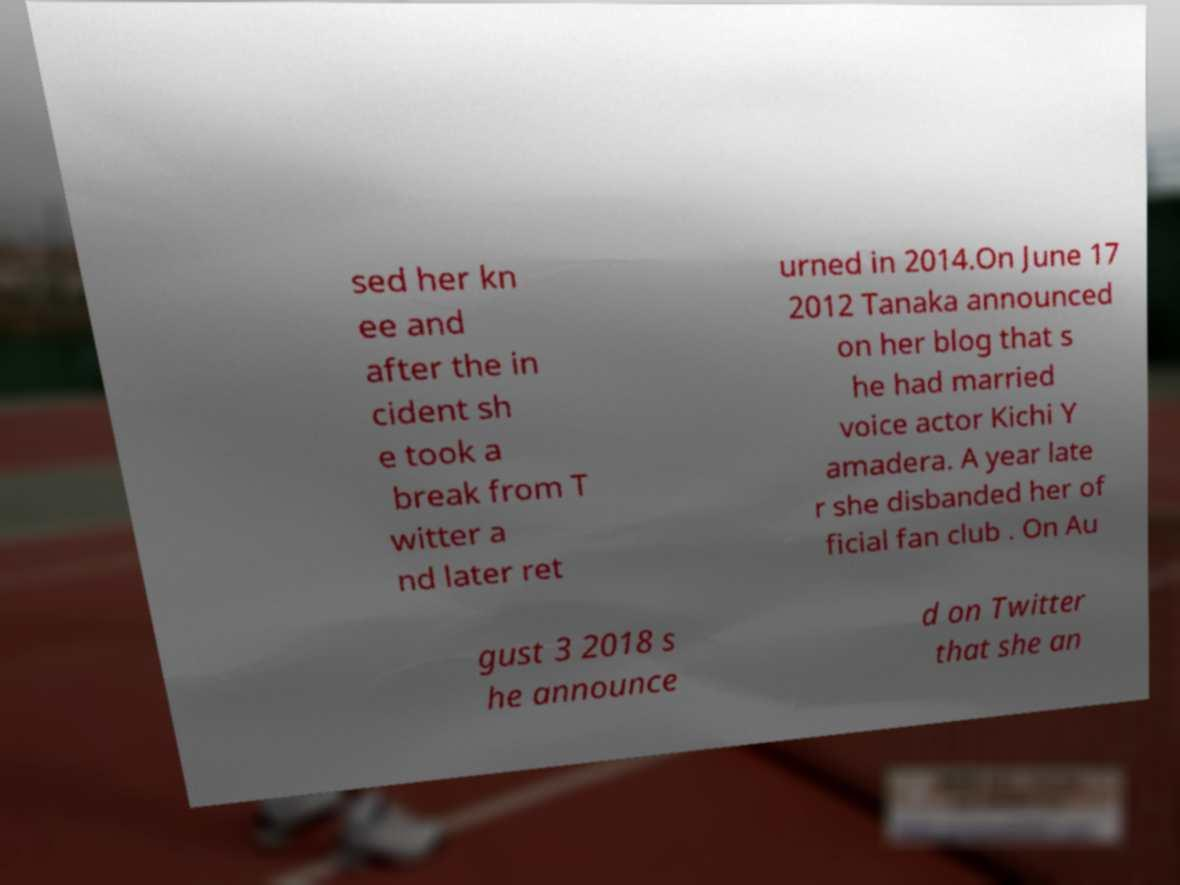Please read and relay the text visible in this image. What does it say? sed her kn ee and after the in cident sh e took a break from T witter a nd later ret urned in 2014.On June 17 2012 Tanaka announced on her blog that s he had married voice actor Kichi Y amadera. A year late r she disbanded her of ficial fan club . On Au gust 3 2018 s he announce d on Twitter that she an 